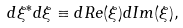<formula> <loc_0><loc_0><loc_500><loc_500>d \xi ^ { * } d \xi \equiv d R e ( \xi ) d I m ( \xi ) ,</formula> 